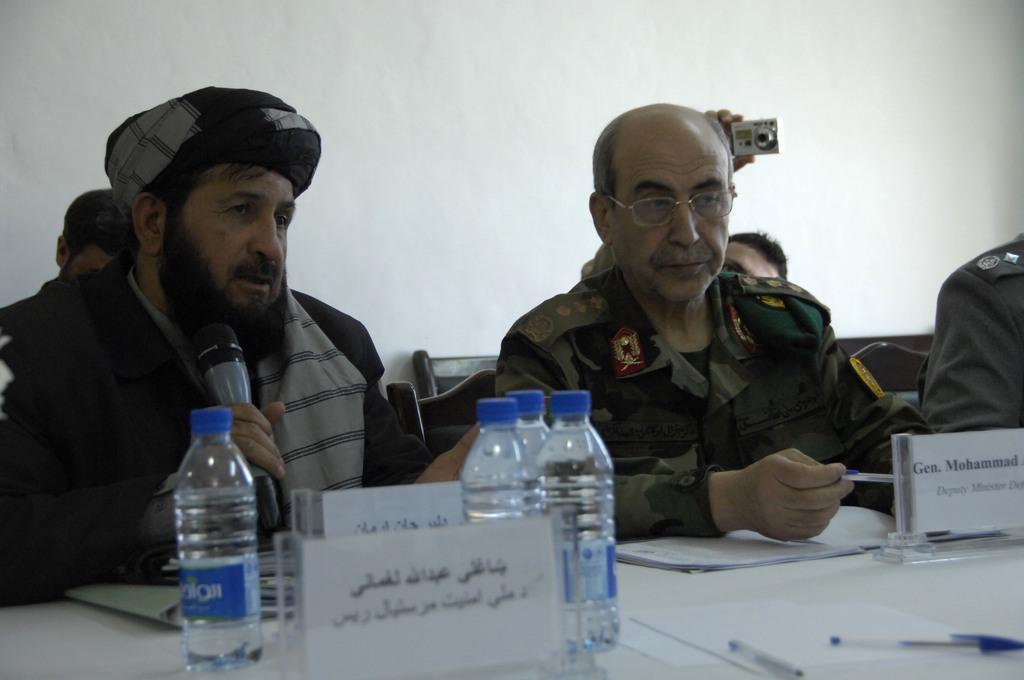Please provide a concise description of this image. In this image, there is a table which is in white color, on that table there are some bottles kept, in the left side there is a man sitting and he is holding a microphone which is in black color, there are some papers on the table, In the background there is a man sitting and he is holding a camera which is in white color he is taking the picture, in the background there is a white color wall. 